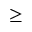Convert formula to latex. <formula><loc_0><loc_0><loc_500><loc_500>\geq</formula> 